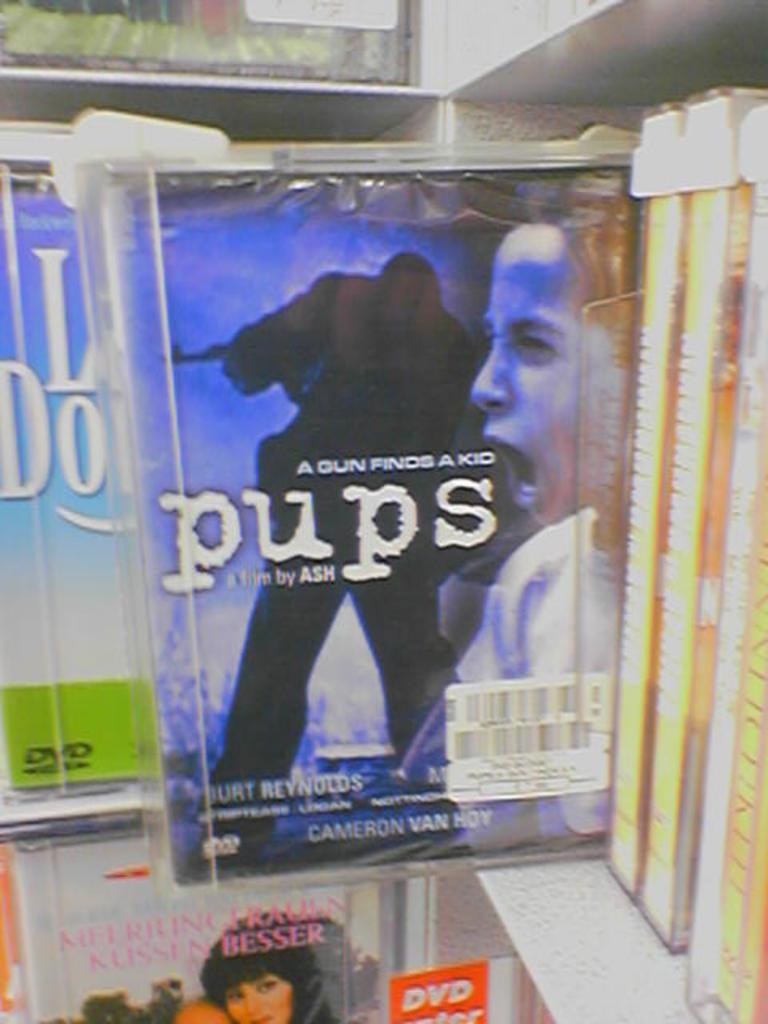Provide a one-sentence caption for the provided image. A DVD cover showing a woman yelling with a shadow figure in the background with the name pups in the foreground. 